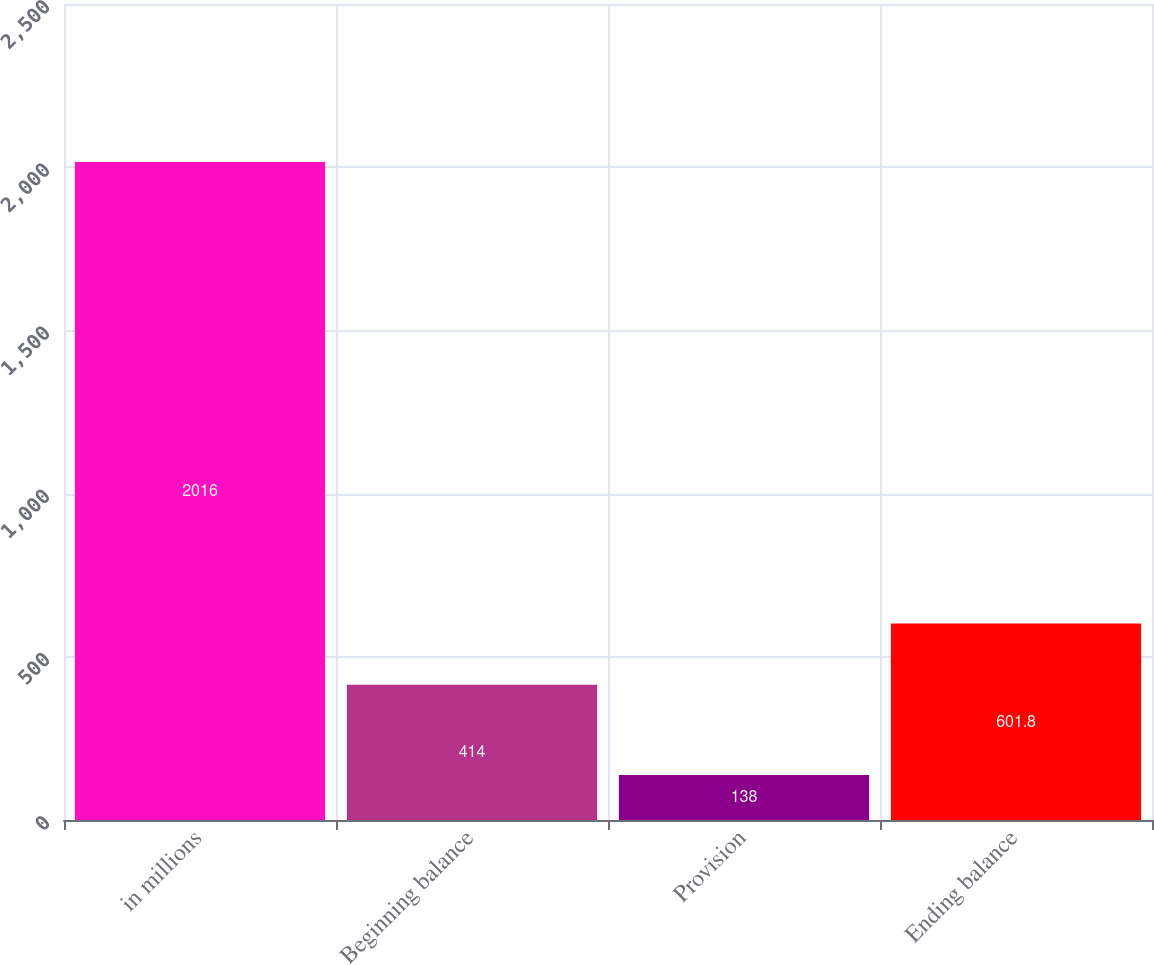Convert chart. <chart><loc_0><loc_0><loc_500><loc_500><bar_chart><fcel>in millions<fcel>Beginning balance<fcel>Provision<fcel>Ending balance<nl><fcel>2016<fcel>414<fcel>138<fcel>601.8<nl></chart> 